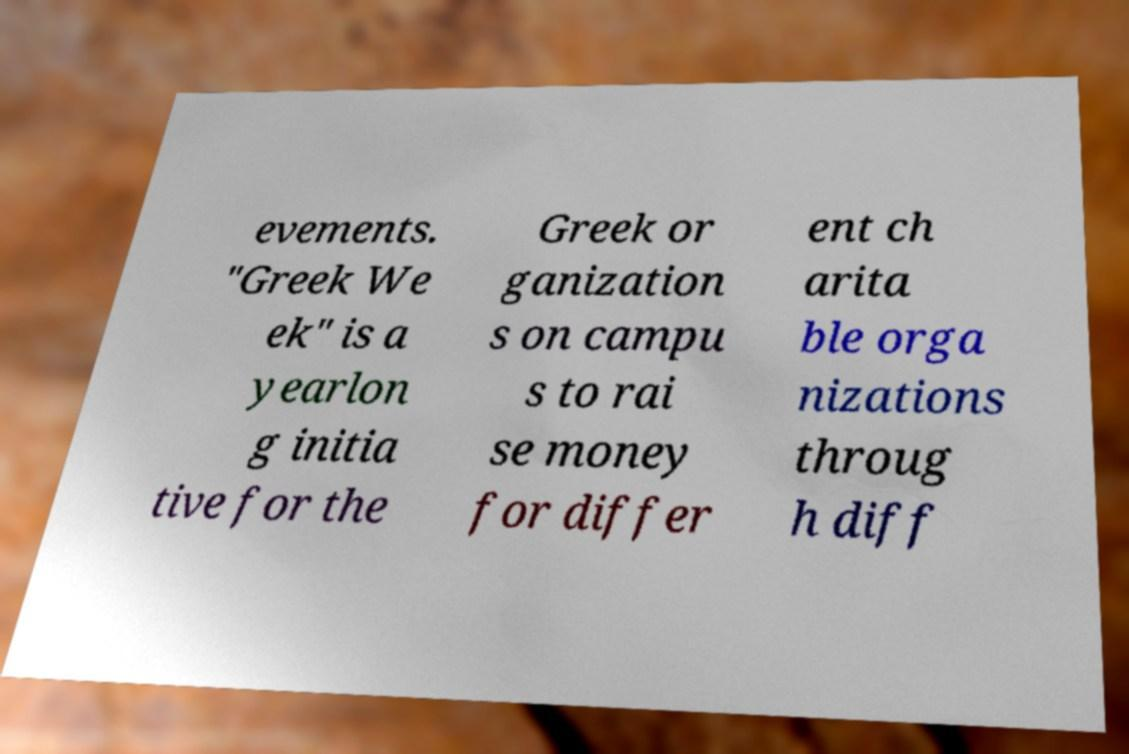What messages or text are displayed in this image? I need them in a readable, typed format. evements. "Greek We ek" is a yearlon g initia tive for the Greek or ganization s on campu s to rai se money for differ ent ch arita ble orga nizations throug h diff 